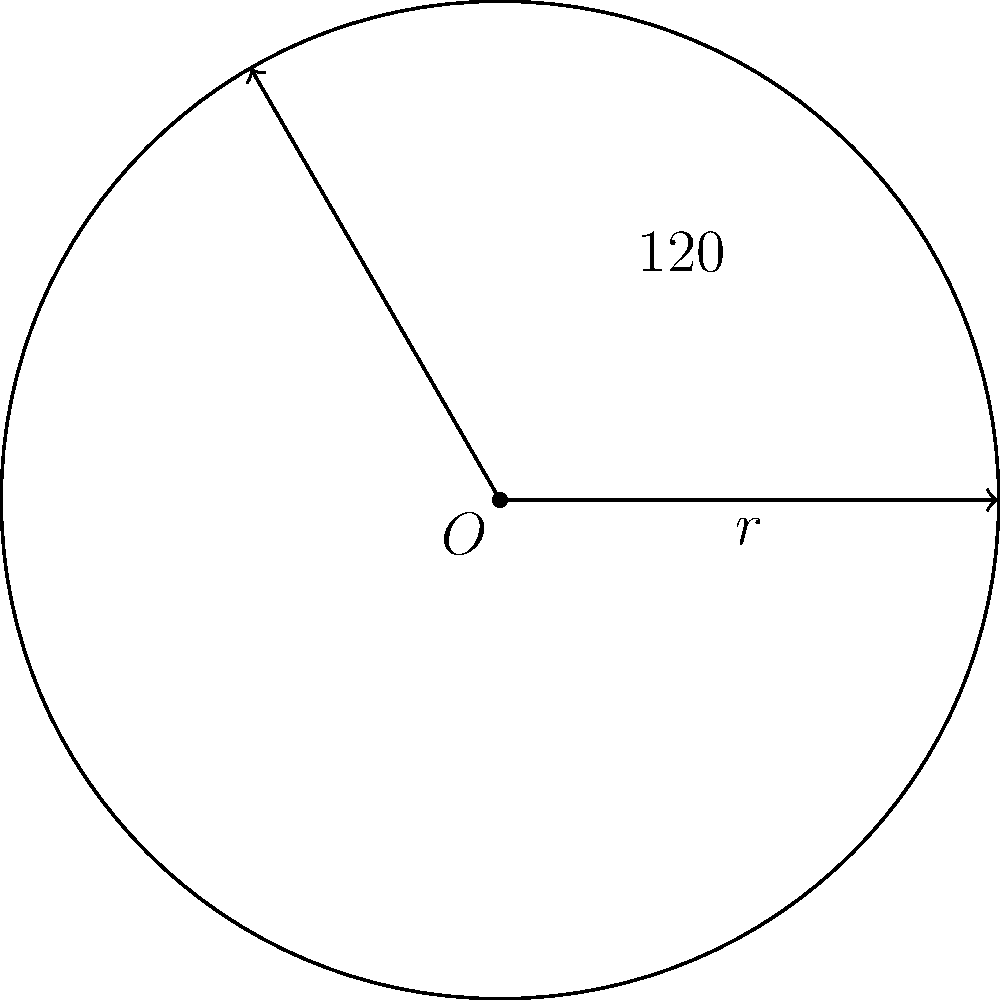As part of a long-term strategic plan for optimizing warehouse space, you're analyzing circular storage units. A circular storage area has a radius of 15 meters. If you need to allocate a sector of this storage area that spans a central angle of 120°, what is the area of this sector in square meters? Round your answer to the nearest whole number. To find the area of a circular sector, we'll follow these steps:

1) The formula for the area of a circular sector is:

   $$A = \frac{1}{2}r^2\theta$$

   Where $A$ is the area, $r$ is the radius, and $\theta$ is the central angle in radians.

2) We're given the radius $r = 15$ meters and the central angle of 120°.

3) We need to convert 120° to radians:
   
   $$\theta = 120° \times \frac{\pi}{180°} = \frac{2\pi}{3} \approx 2.0944 \text{ radians}$$

4) Now we can substitute these values into our formula:

   $$A = \frac{1}{2} \times 15^2 \times \frac{2\pi}{3}$$

5) Let's calculate:
   
   $$A = \frac{1}{2} \times 225 \times \frac{2\pi}{3} = 75\pi \approx 235.62 \text{ square meters}$$

6) Rounding to the nearest whole number:

   $$A \approx 236 \text{ square meters}$$
Answer: 236 square meters 